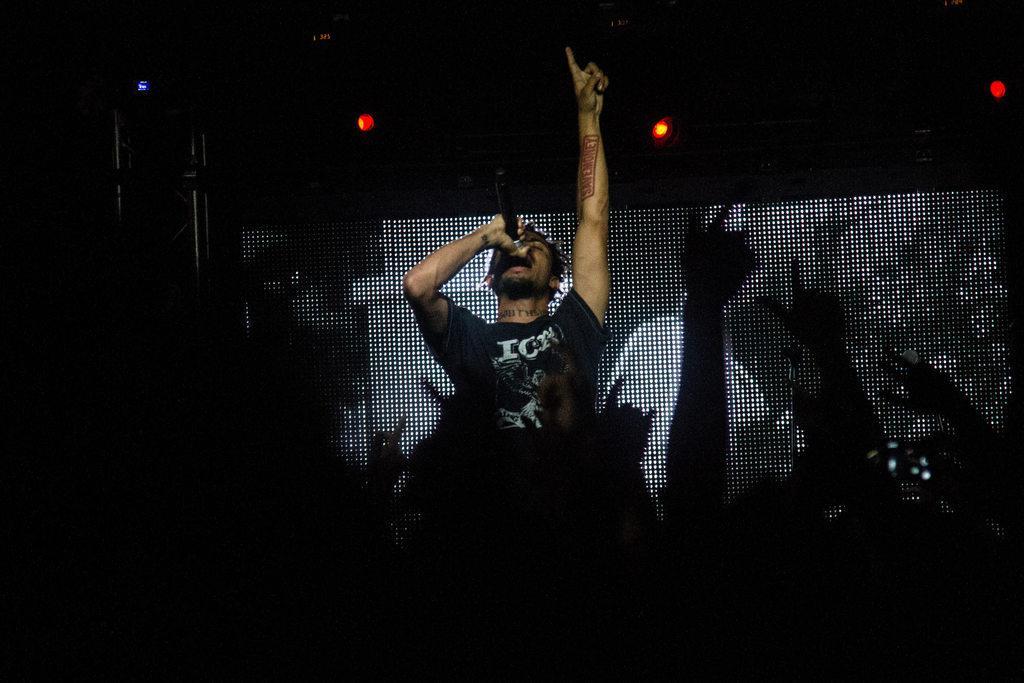Describe this image in one or two sentences. This image consists of a man singing. It looks like a concert. In the background, we can see a screen. On the left, there is a stand. At the top, there are lights in red color. 